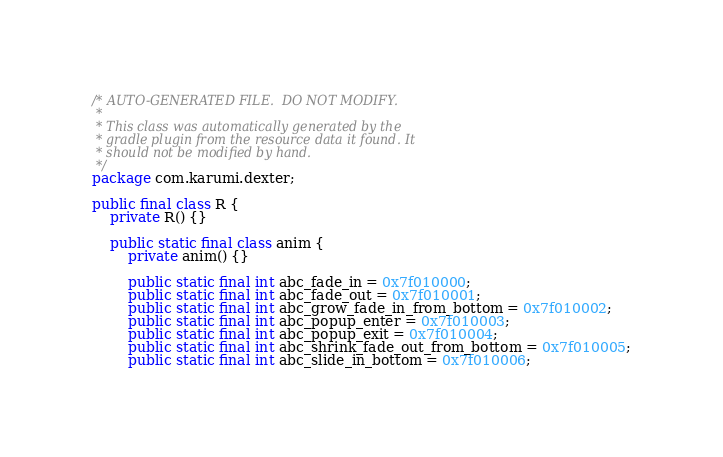Convert code to text. <code><loc_0><loc_0><loc_500><loc_500><_Java_>/* AUTO-GENERATED FILE.  DO NOT MODIFY.
 *
 * This class was automatically generated by the
 * gradle plugin from the resource data it found. It
 * should not be modified by hand.
 */
package com.karumi.dexter;

public final class R {
    private R() {}

    public static final class anim {
        private anim() {}

        public static final int abc_fade_in = 0x7f010000;
        public static final int abc_fade_out = 0x7f010001;
        public static final int abc_grow_fade_in_from_bottom = 0x7f010002;
        public static final int abc_popup_enter = 0x7f010003;
        public static final int abc_popup_exit = 0x7f010004;
        public static final int abc_shrink_fade_out_from_bottom = 0x7f010005;
        public static final int abc_slide_in_bottom = 0x7f010006;</code> 